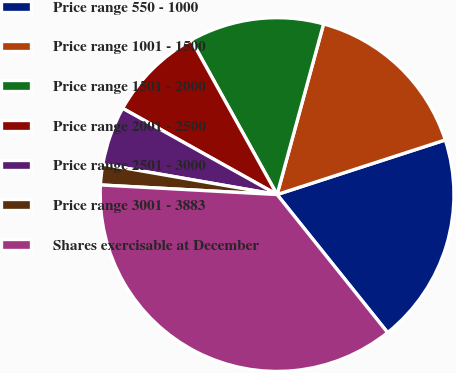Convert chart. <chart><loc_0><loc_0><loc_500><loc_500><pie_chart><fcel>Price range 550 - 1000<fcel>Price range 1001 - 1500<fcel>Price range 1501 - 2000<fcel>Price range 2001 - 2500<fcel>Price range 2501 - 3000<fcel>Price range 3001 - 3883<fcel>Shares exercisable at December<nl><fcel>19.25%<fcel>15.77%<fcel>12.3%<fcel>8.83%<fcel>5.36%<fcel>1.88%<fcel>36.61%<nl></chart> 